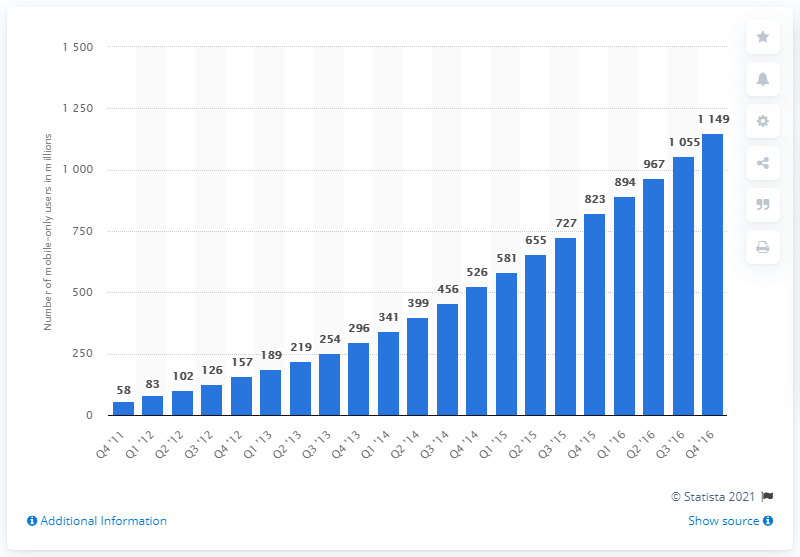Specify some key components in this picture. As of the fourth quarter of 2016, approximately 823 million Facebook users accessed the social media site exclusively via mobile device in a given month. In the fourth quarter of 2016, there were 823 mobile-only users. 